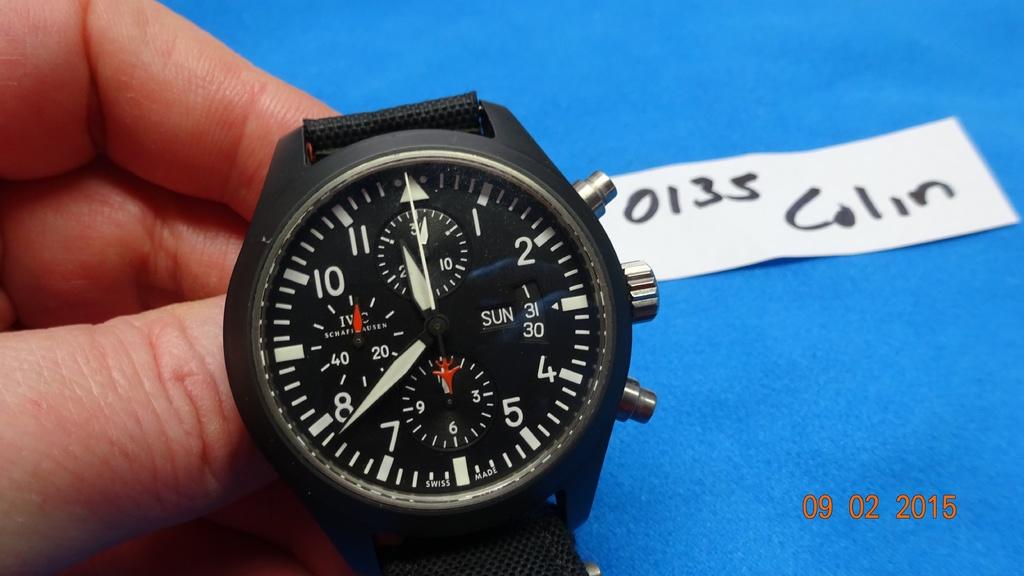What day of the month is shown on the watch?
Offer a very short reply. 31. What is the name on the white tag?
Offer a terse response. Colin. 